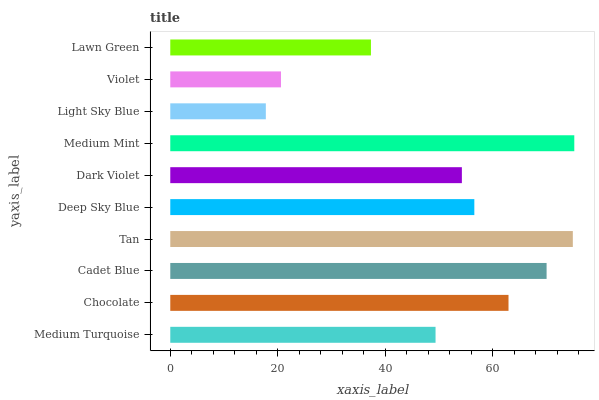Is Light Sky Blue the minimum?
Answer yes or no. Yes. Is Medium Mint the maximum?
Answer yes or no. Yes. Is Chocolate the minimum?
Answer yes or no. No. Is Chocolate the maximum?
Answer yes or no. No. Is Chocolate greater than Medium Turquoise?
Answer yes or no. Yes. Is Medium Turquoise less than Chocolate?
Answer yes or no. Yes. Is Medium Turquoise greater than Chocolate?
Answer yes or no. No. Is Chocolate less than Medium Turquoise?
Answer yes or no. No. Is Deep Sky Blue the high median?
Answer yes or no. Yes. Is Dark Violet the low median?
Answer yes or no. Yes. Is Medium Turquoise the high median?
Answer yes or no. No. Is Light Sky Blue the low median?
Answer yes or no. No. 